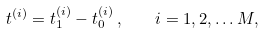Convert formula to latex. <formula><loc_0><loc_0><loc_500><loc_500>t ^ { ( i ) } = t _ { 1 } ^ { ( i ) } - t _ { 0 } ^ { ( i ) } \, , \quad i = 1 , 2 , \dots M ,</formula> 